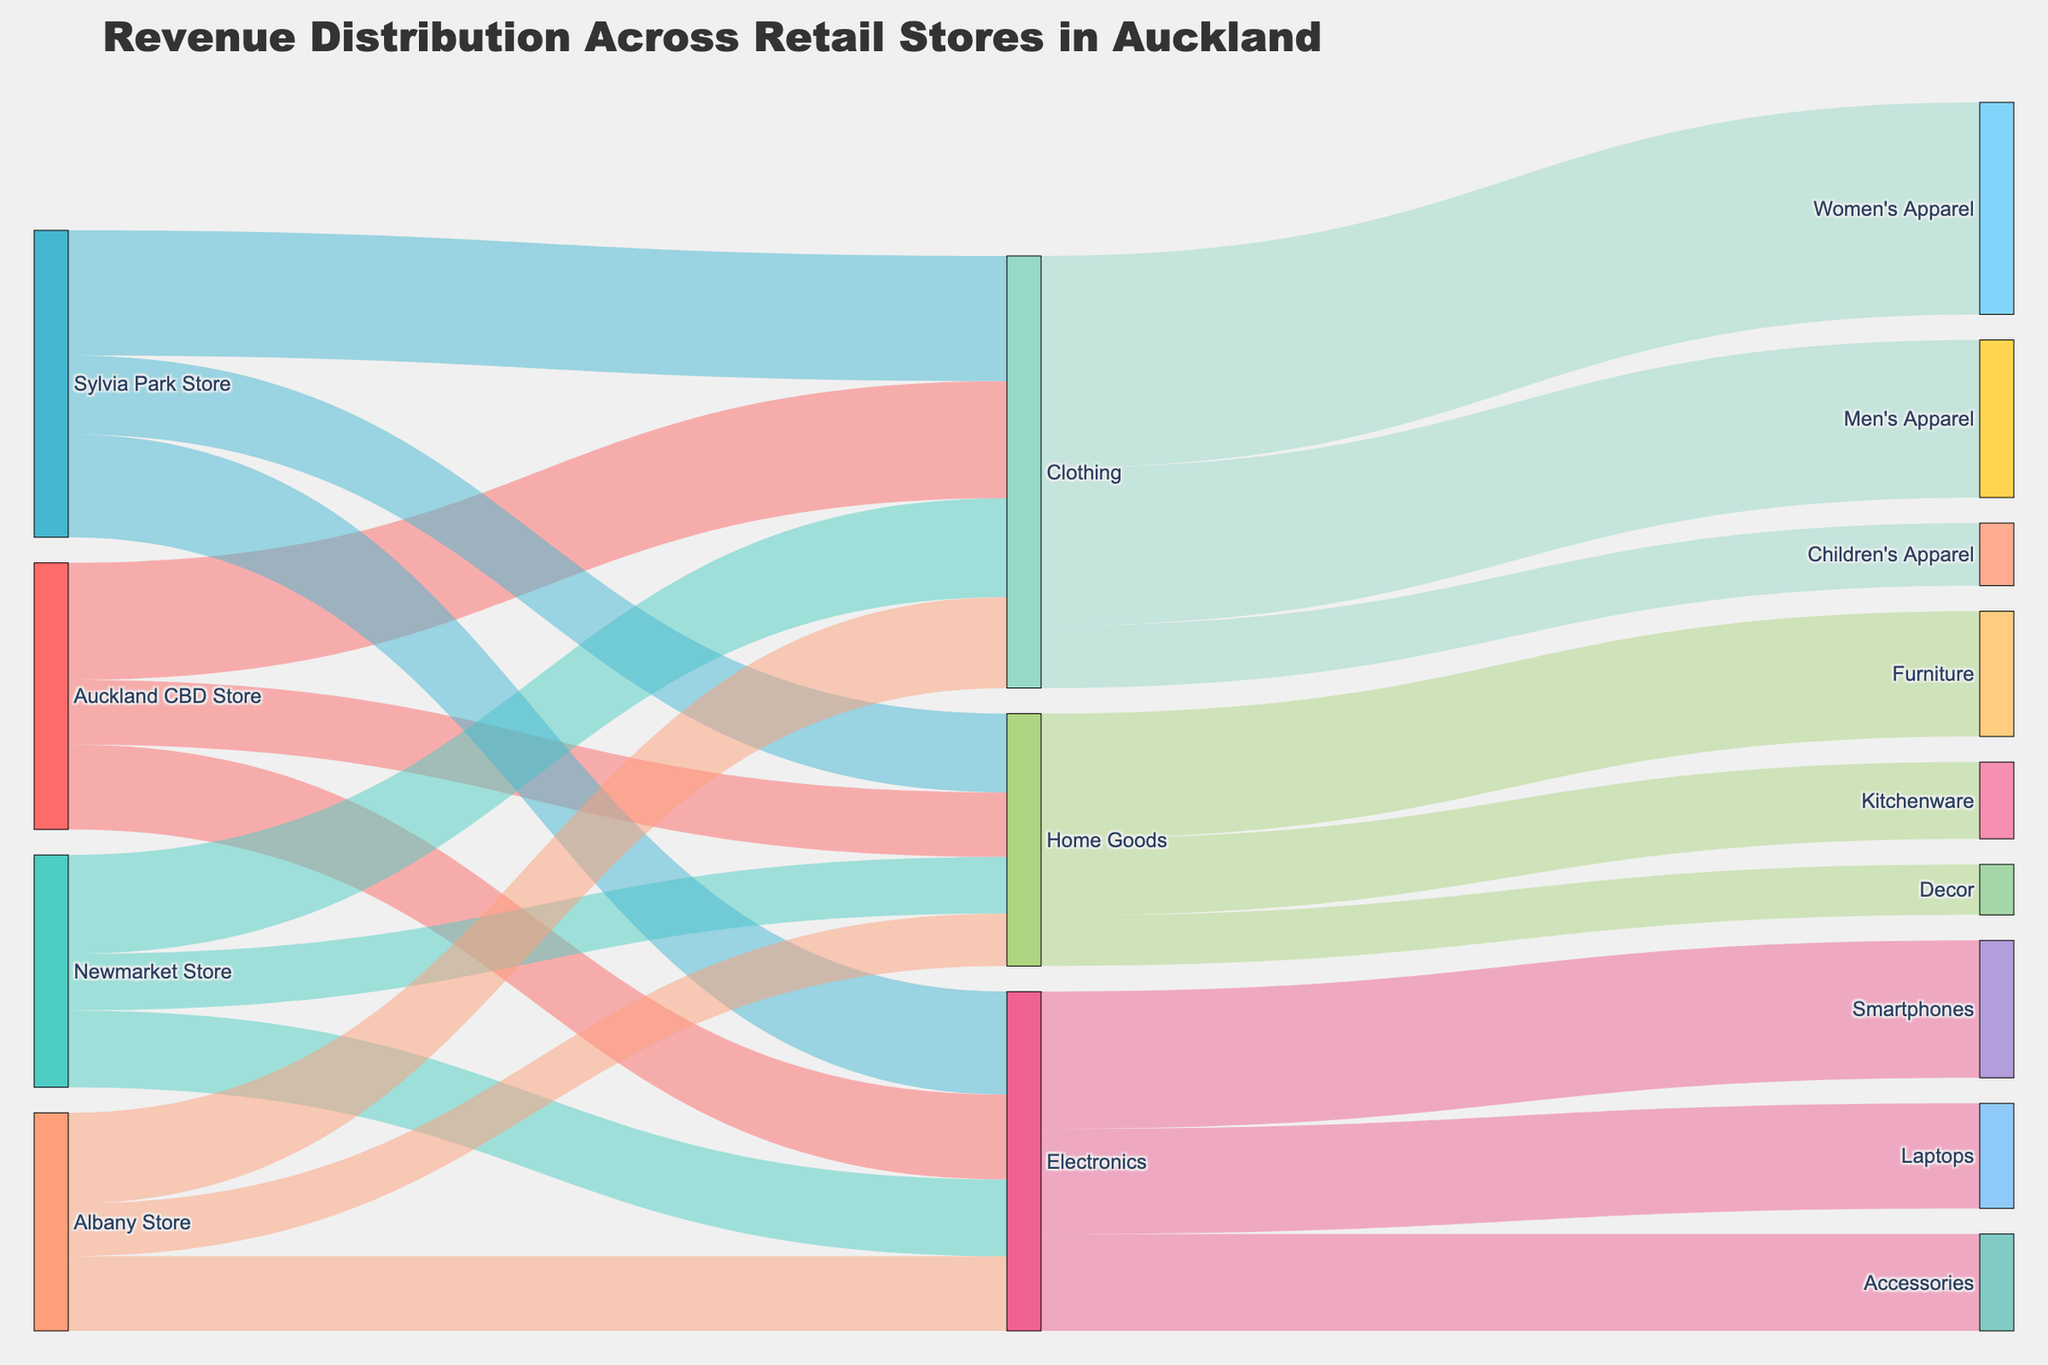what's the title of the figure? The title of the figure is presented at the top and provides a summary of what the diagram is about.
Answer: Revenue Distribution Across Retail Stores in Auckland Which store generated the highest revenue in Clothing category? To determine this, look at the branches that end at the 'Clothing' node from their respective store nodes. The Sylvia Park Store has the largest flow to 'Clothing'.
Answer: Sylvia Park Store What is the total revenue generated from Home Goods category? Sum the values flowing into 'Home Goods' from all stores: 320000 (Auckland CBD) + 280000 (Newmarket) + 390000 (Sylvia Park) + 260000 (Albany).
Answer: 1250000 Which product subcategory in Electronics has the least revenue? To find the product subcategory with the least revenue, compare the values flowing into 'Smartphones', 'Laptops', and 'Accessories' from 'Electronics'. Accessories has the least flow.
Answer: Accessories Which store has the smallest contribution to the total revenue in Auckland? Compare the sum of all revenue segments for each store: Auckland CBD (580000+420000+320000), Newmarket (490000+380000+280000), Sylvia Park (620000+510000+390000), Albany (450000+370000+260000). The Albany Store has the smallest total.
Answer: Albany Store What is the combined revenue from Women's Apparel and Men's Apparel? Sum the values flowing into 'Women's Apparel' and 'Men's Apparel' from 'Clothing': 1050000 (Women's Apparel) + 780000 (Men's Apparel).
Answer: 1830000 Which category among Clothing, Electronics, and Home Goods has the highest overall revenue contribution? Compare the total values flowing into 'Clothing', 'Electronics', and 'Home Goods'. Sum up each individual flow: Clothing (580000+490000+620000+450000), Electronics (420000+380000+510000+370000), Home Goods (320000+280000+390000+260000). Clothing has the highest overall contribution.
Answer: Clothing Compare the revenue share of 'Newmarket Store' and 'Albany Store' in the Electronics category. Which one is higher? Compare the flows from Newmarket Store to Electronics and Albany Store to Electronics: 380000 (Newmarket) > 370000 (Albany).
Answer: Newmarket Store What's the revenue sum for all product subcategories under Home Goods? Sum the revenue values flowing from 'Home Goods' to its subcategories: 620000 (Furniture) + 380000 (Kitchenware) + 250000 (Decor).
Answer: 1250000 